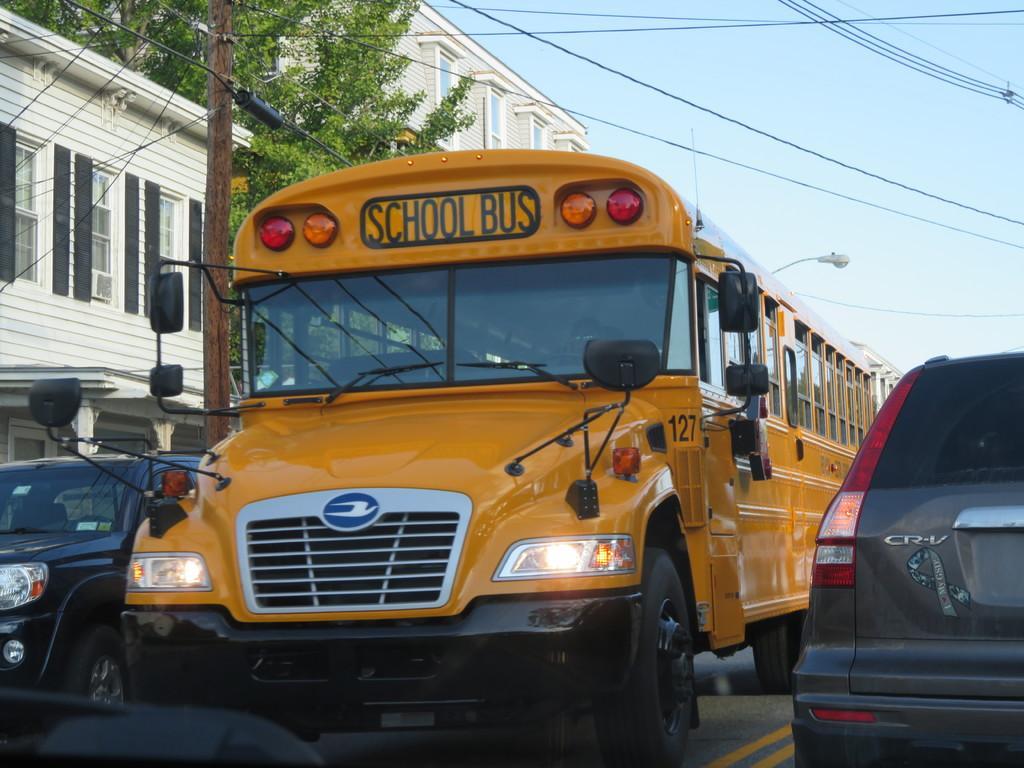In one or two sentences, can you explain what this image depicts? In this picture we can see some vehicles on the road and behind the vehicles there is an electric pole with cables and another pole with a light. Behind the pole there is a tree, buildings and a sky. 